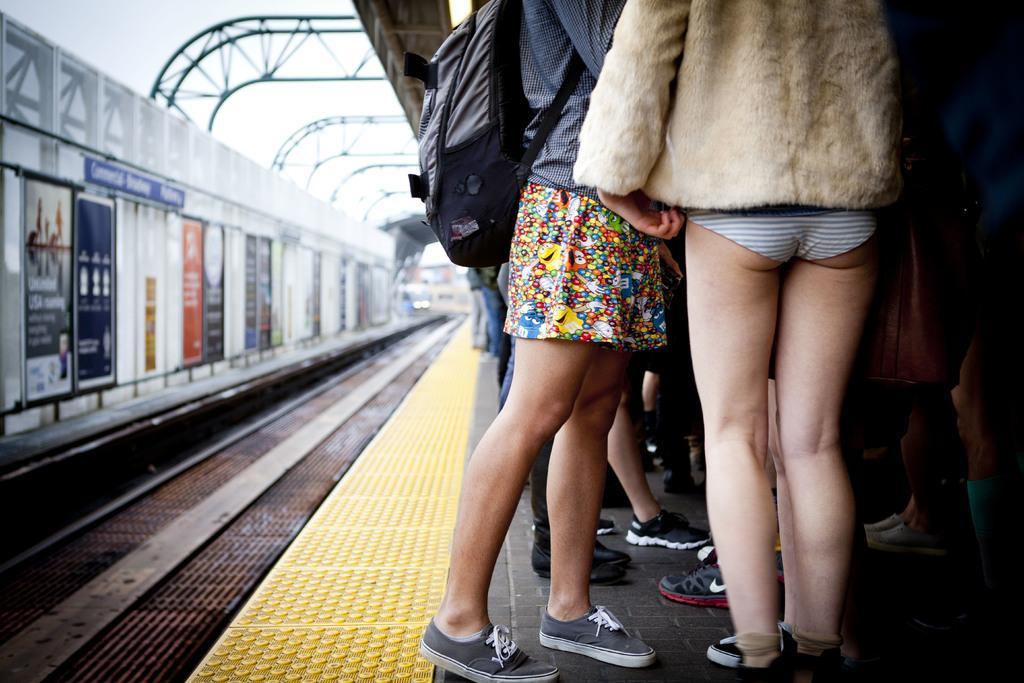Please provide a concise description of this image. On the right there is a woman who is wearing brown color jacket, short and shoe. Beside her we can see another woman who is wearing top, short, shoe and bag. In the background we can see many people standing on the platform. On the bottom left corner we can see railway track. On the left we can see many advertisement boards on the steel wall. In the background we can see train and buildings. Here it's a sky. 